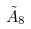Convert formula to latex. <formula><loc_0><loc_0><loc_500><loc_500>\tilde { A } _ { 8 }</formula> 